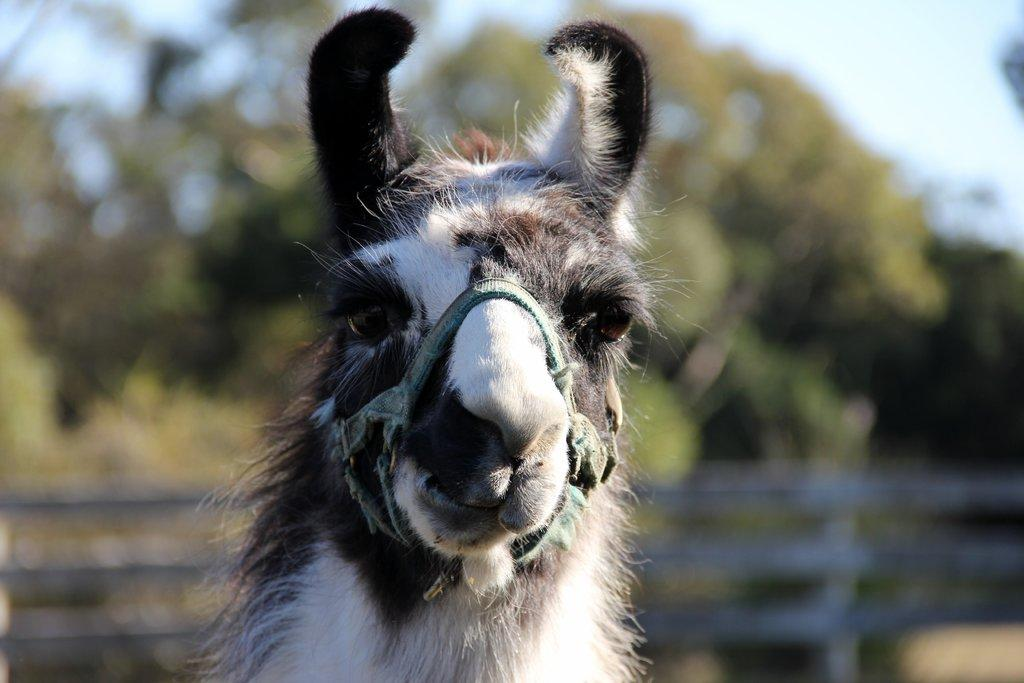What type of animal can be seen in the image? There is an animal in the image, and it is white and black in color. How is the animal secured or restrained in the image? The animal is tied with a belt in the image. What can be seen in the background of the image? There is fencing, trees, and the sky visible in the background of the image. What type of pocket can be seen on the animal in the image? There is no pocket visible on the animal in the image. What type of competition is the animal participating in within the image? There is no competition depicted in the image; it simply shows an animal tied with a belt. 